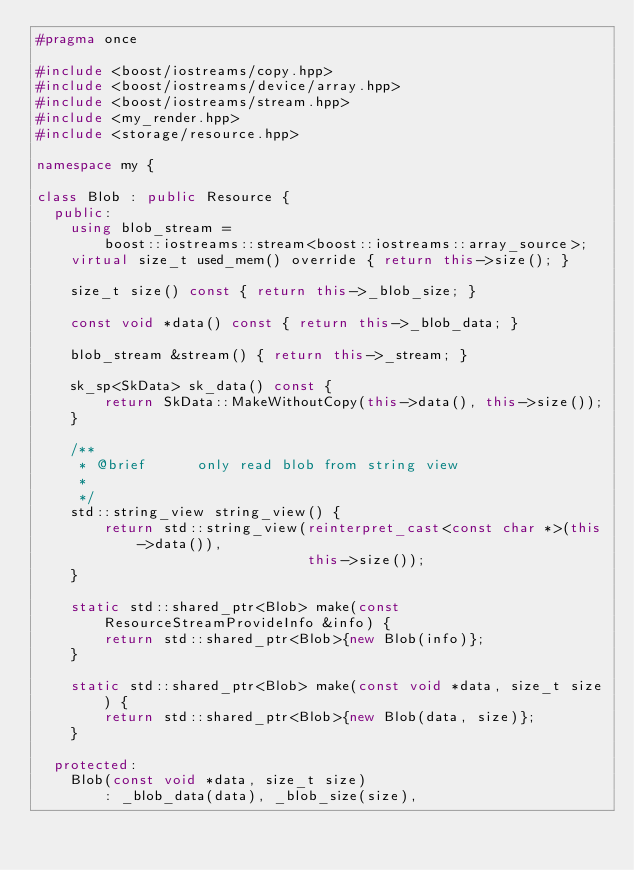<code> <loc_0><loc_0><loc_500><loc_500><_C++_>#pragma once

#include <boost/iostreams/copy.hpp>
#include <boost/iostreams/device/array.hpp>
#include <boost/iostreams/stream.hpp>
#include <my_render.hpp>
#include <storage/resource.hpp>

namespace my {

class Blob : public Resource {
  public:
    using blob_stream =
        boost::iostreams::stream<boost::iostreams::array_source>;
    virtual size_t used_mem() override { return this->size(); }

    size_t size() const { return this->_blob_size; }

    const void *data() const { return this->_blob_data; }

    blob_stream &stream() { return this->_stream; }

    sk_sp<SkData> sk_data() const {
        return SkData::MakeWithoutCopy(this->data(), this->size());
    }

    /**
     * @brief      only read blob from string view
     *
     */
    std::string_view string_view() {
        return std::string_view(reinterpret_cast<const char *>(this->data()),
                                this->size());
    }

    static std::shared_ptr<Blob> make(const ResourceStreamProvideInfo &info) {
        return std::shared_ptr<Blob>{new Blob(info)};
    }

    static std::shared_ptr<Blob> make(const void *data, size_t size) {
        return std::shared_ptr<Blob>{new Blob(data, size)};
    }

  protected:
    Blob(const void *data, size_t size)
        : _blob_data(data), _blob_size(size),</code> 